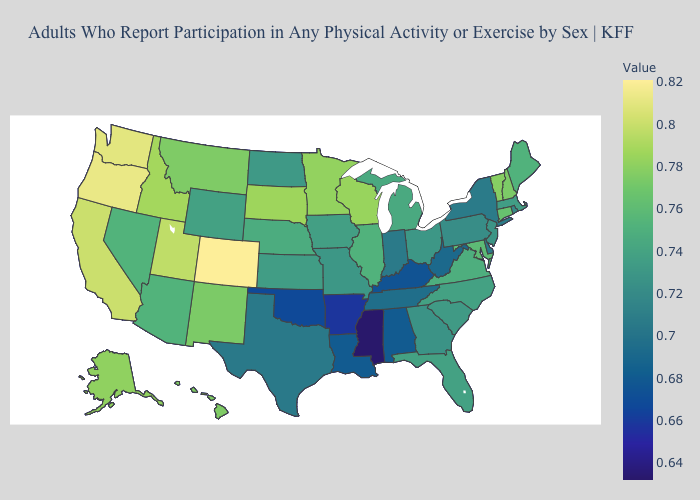Does Mississippi have the lowest value in the South?
Concise answer only. Yes. Among the states that border Vermont , does New York have the lowest value?
Be succinct. Yes. Does the map have missing data?
Write a very short answer. No. Does Wyoming have the lowest value in the West?
Keep it brief. Yes. Is the legend a continuous bar?
Quick response, please. Yes. Among the states that border New York , does Vermont have the lowest value?
Concise answer only. No. 